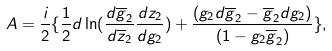Convert formula to latex. <formula><loc_0><loc_0><loc_500><loc_500>A = \frac { i } { 2 } \{ \frac { 1 } { 2 } d \ln ( \frac { d \overline { g } _ { 2 } } { d \overline { z } _ { 2 } } \frac { d z _ { 2 } } { d g _ { 2 } } ) + \frac { ( g _ { 2 } d \overline { g } _ { 2 } - \overline { g } _ { 2 } d g _ { 2 } ) } { ( 1 - g _ { 2 } \overline { g } _ { 2 } ) } \} ,</formula> 